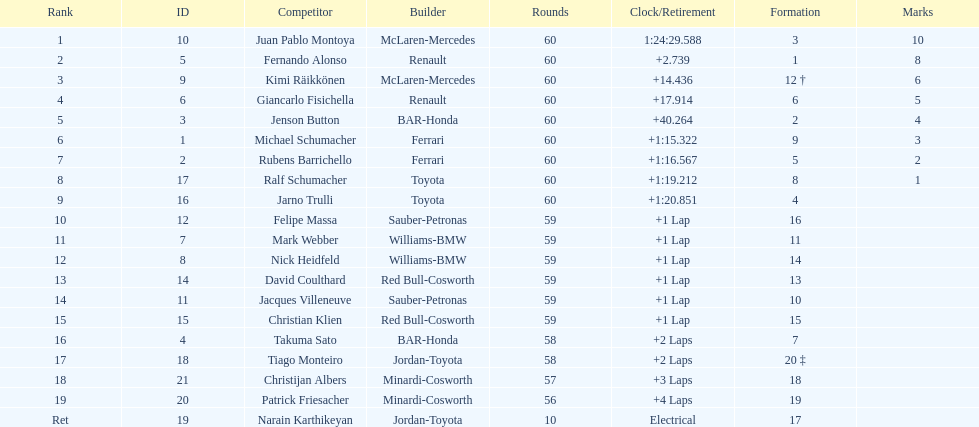Which driver came after giancarlo fisichella? Jenson Button. I'm looking to parse the entire table for insights. Could you assist me with that? {'header': ['Rank', 'ID', 'Competitor', 'Builder', 'Rounds', 'Clock/Retirement', 'Formation', 'Marks'], 'rows': [['1', '10', 'Juan Pablo Montoya', 'McLaren-Mercedes', '60', '1:24:29.588', '3', '10'], ['2', '5', 'Fernando Alonso', 'Renault', '60', '+2.739', '1', '8'], ['3', '9', 'Kimi Räikkönen', 'McLaren-Mercedes', '60', '+14.436', '12 †', '6'], ['4', '6', 'Giancarlo Fisichella', 'Renault', '60', '+17.914', '6', '5'], ['5', '3', 'Jenson Button', 'BAR-Honda', '60', '+40.264', '2', '4'], ['6', '1', 'Michael Schumacher', 'Ferrari', '60', '+1:15.322', '9', '3'], ['7', '2', 'Rubens Barrichello', 'Ferrari', '60', '+1:16.567', '5', '2'], ['8', '17', 'Ralf Schumacher', 'Toyota', '60', '+1:19.212', '8', '1'], ['9', '16', 'Jarno Trulli', 'Toyota', '60', '+1:20.851', '4', ''], ['10', '12', 'Felipe Massa', 'Sauber-Petronas', '59', '+1 Lap', '16', ''], ['11', '7', 'Mark Webber', 'Williams-BMW', '59', '+1 Lap', '11', ''], ['12', '8', 'Nick Heidfeld', 'Williams-BMW', '59', '+1 Lap', '14', ''], ['13', '14', 'David Coulthard', 'Red Bull-Cosworth', '59', '+1 Lap', '13', ''], ['14', '11', 'Jacques Villeneuve', 'Sauber-Petronas', '59', '+1 Lap', '10', ''], ['15', '15', 'Christian Klien', 'Red Bull-Cosworth', '59', '+1 Lap', '15', ''], ['16', '4', 'Takuma Sato', 'BAR-Honda', '58', '+2 Laps', '7', ''], ['17', '18', 'Tiago Monteiro', 'Jordan-Toyota', '58', '+2 Laps', '20 ‡', ''], ['18', '21', 'Christijan Albers', 'Minardi-Cosworth', '57', '+3 Laps', '18', ''], ['19', '20', 'Patrick Friesacher', 'Minardi-Cosworth', '56', '+4 Laps', '19', ''], ['Ret', '19', 'Narain Karthikeyan', 'Jordan-Toyota', '10', 'Electrical', '17', '']]} 